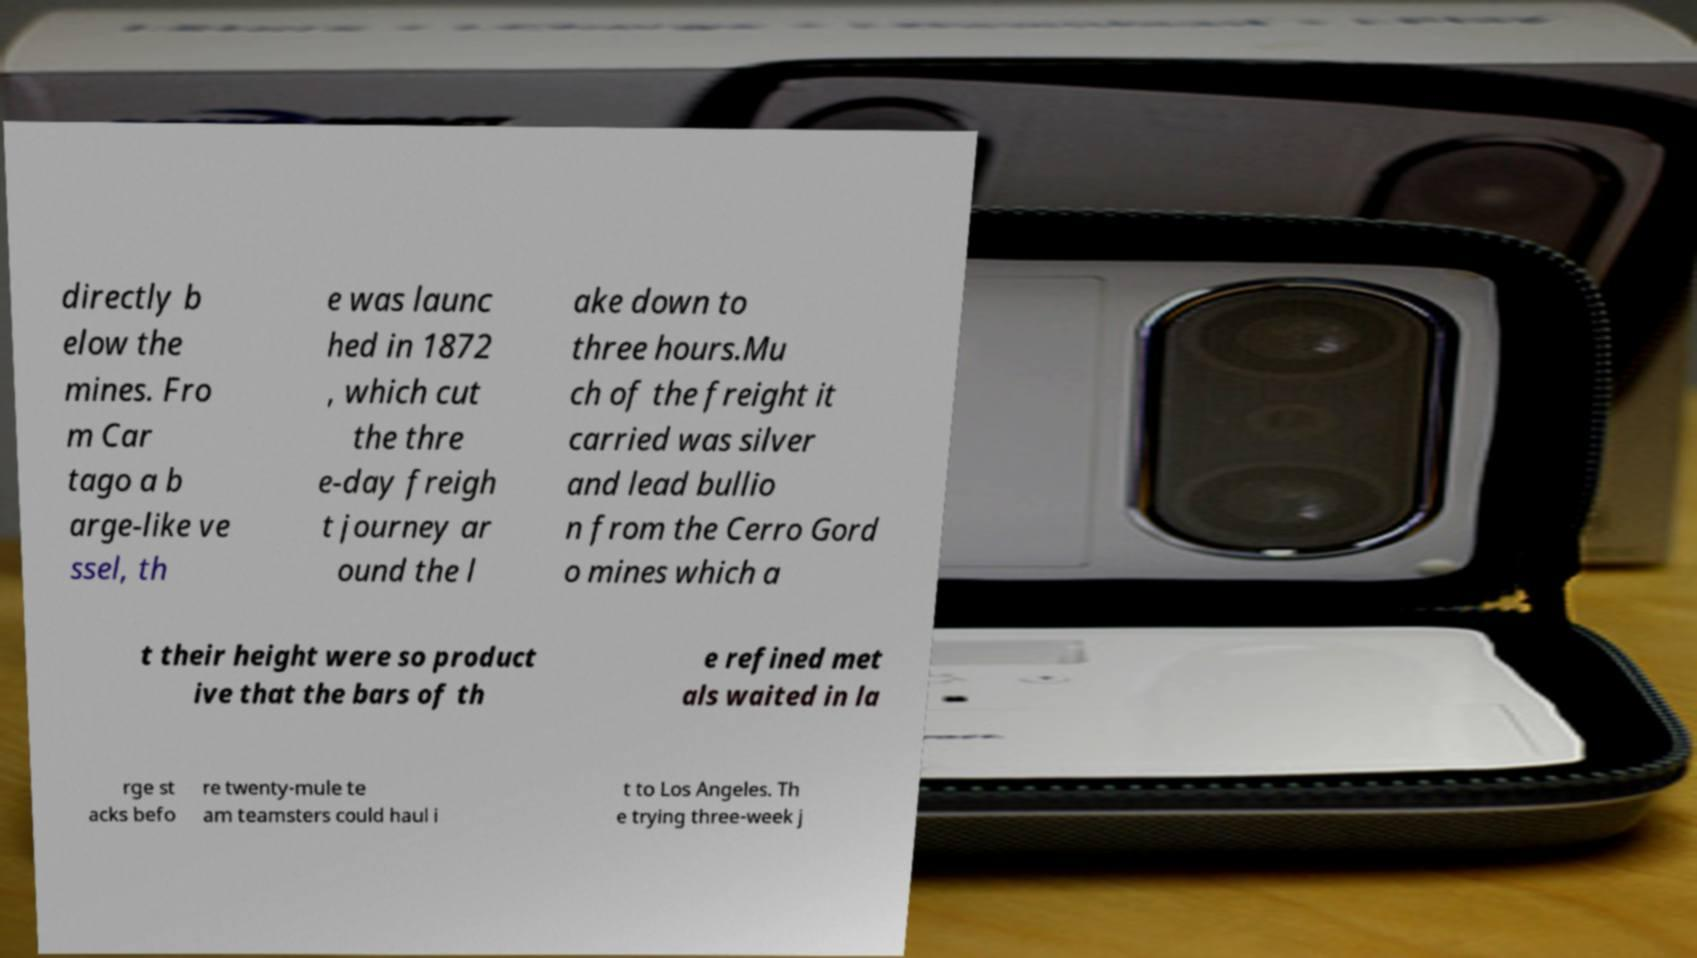Can you accurately transcribe the text from the provided image for me? directly b elow the mines. Fro m Car tago a b arge-like ve ssel, th e was launc hed in 1872 , which cut the thre e-day freigh t journey ar ound the l ake down to three hours.Mu ch of the freight it carried was silver and lead bullio n from the Cerro Gord o mines which a t their height were so product ive that the bars of th e refined met als waited in la rge st acks befo re twenty-mule te am teamsters could haul i t to Los Angeles. Th e trying three-week j 